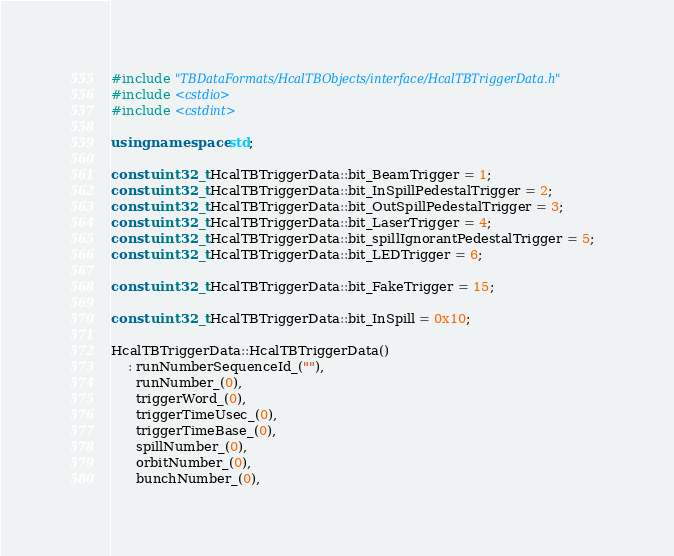<code> <loc_0><loc_0><loc_500><loc_500><_C++_>#include "TBDataFormats/HcalTBObjects/interface/HcalTBTriggerData.h"
#include <cstdio>
#include <cstdint>

using namespace std;

const uint32_t HcalTBTriggerData::bit_BeamTrigger = 1;
const uint32_t HcalTBTriggerData::bit_InSpillPedestalTrigger = 2;
const uint32_t HcalTBTriggerData::bit_OutSpillPedestalTrigger = 3;
const uint32_t HcalTBTriggerData::bit_LaserTrigger = 4;
const uint32_t HcalTBTriggerData::bit_spillIgnorantPedestalTrigger = 5;
const uint32_t HcalTBTriggerData::bit_LEDTrigger = 6;

const uint32_t HcalTBTriggerData::bit_FakeTrigger = 15;

const uint32_t HcalTBTriggerData::bit_InSpill = 0x10;

HcalTBTriggerData::HcalTBTriggerData()
    : runNumberSequenceId_(""),
      runNumber_(0),
      triggerWord_(0),
      triggerTimeUsec_(0),
      triggerTimeBase_(0),
      spillNumber_(0),
      orbitNumber_(0),
      bunchNumber_(0),</code> 